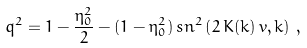Convert formula to latex. <formula><loc_0><loc_0><loc_500><loc_500>q ^ { 2 } = 1 - { \frac { \eta _ { 0 } ^ { 2 } } { 2 } } - ( 1 - \eta _ { 0 } ^ { 2 } ) \, s n ^ { 2 } \left ( 2 \, K ( k ) \, v , k \right ) \, ,</formula> 